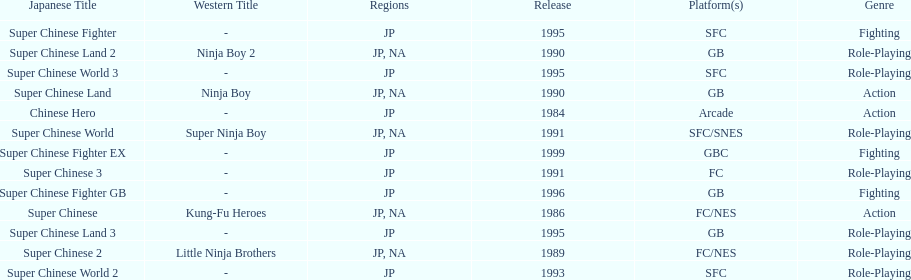When was the last super chinese game released? 1999. 